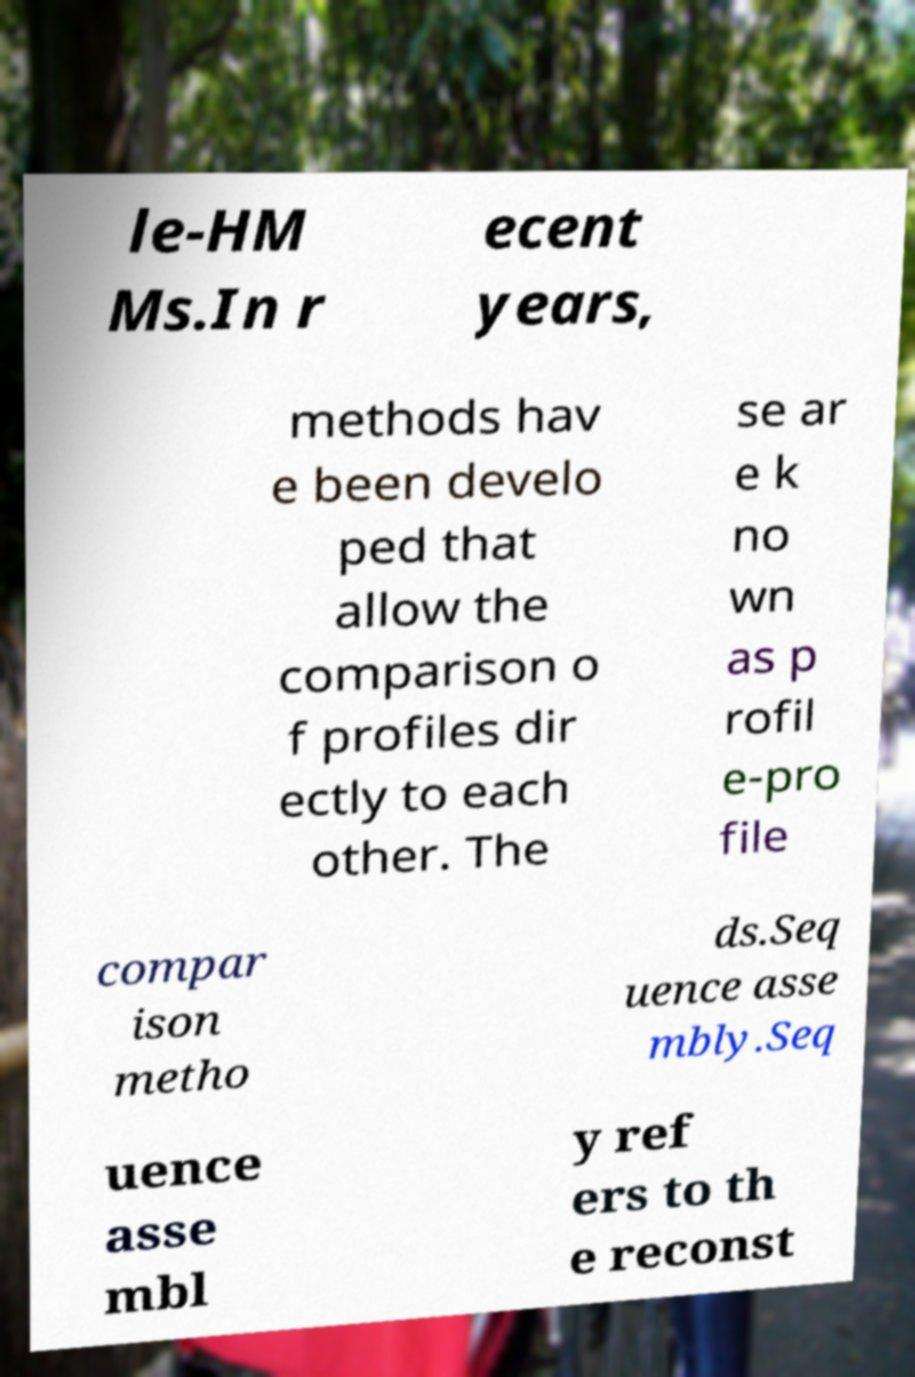Please read and relay the text visible in this image. What does it say? le-HM Ms.In r ecent years, methods hav e been develo ped that allow the comparison o f profiles dir ectly to each other. The se ar e k no wn as p rofil e-pro file compar ison metho ds.Seq uence asse mbly.Seq uence asse mbl y ref ers to th e reconst 